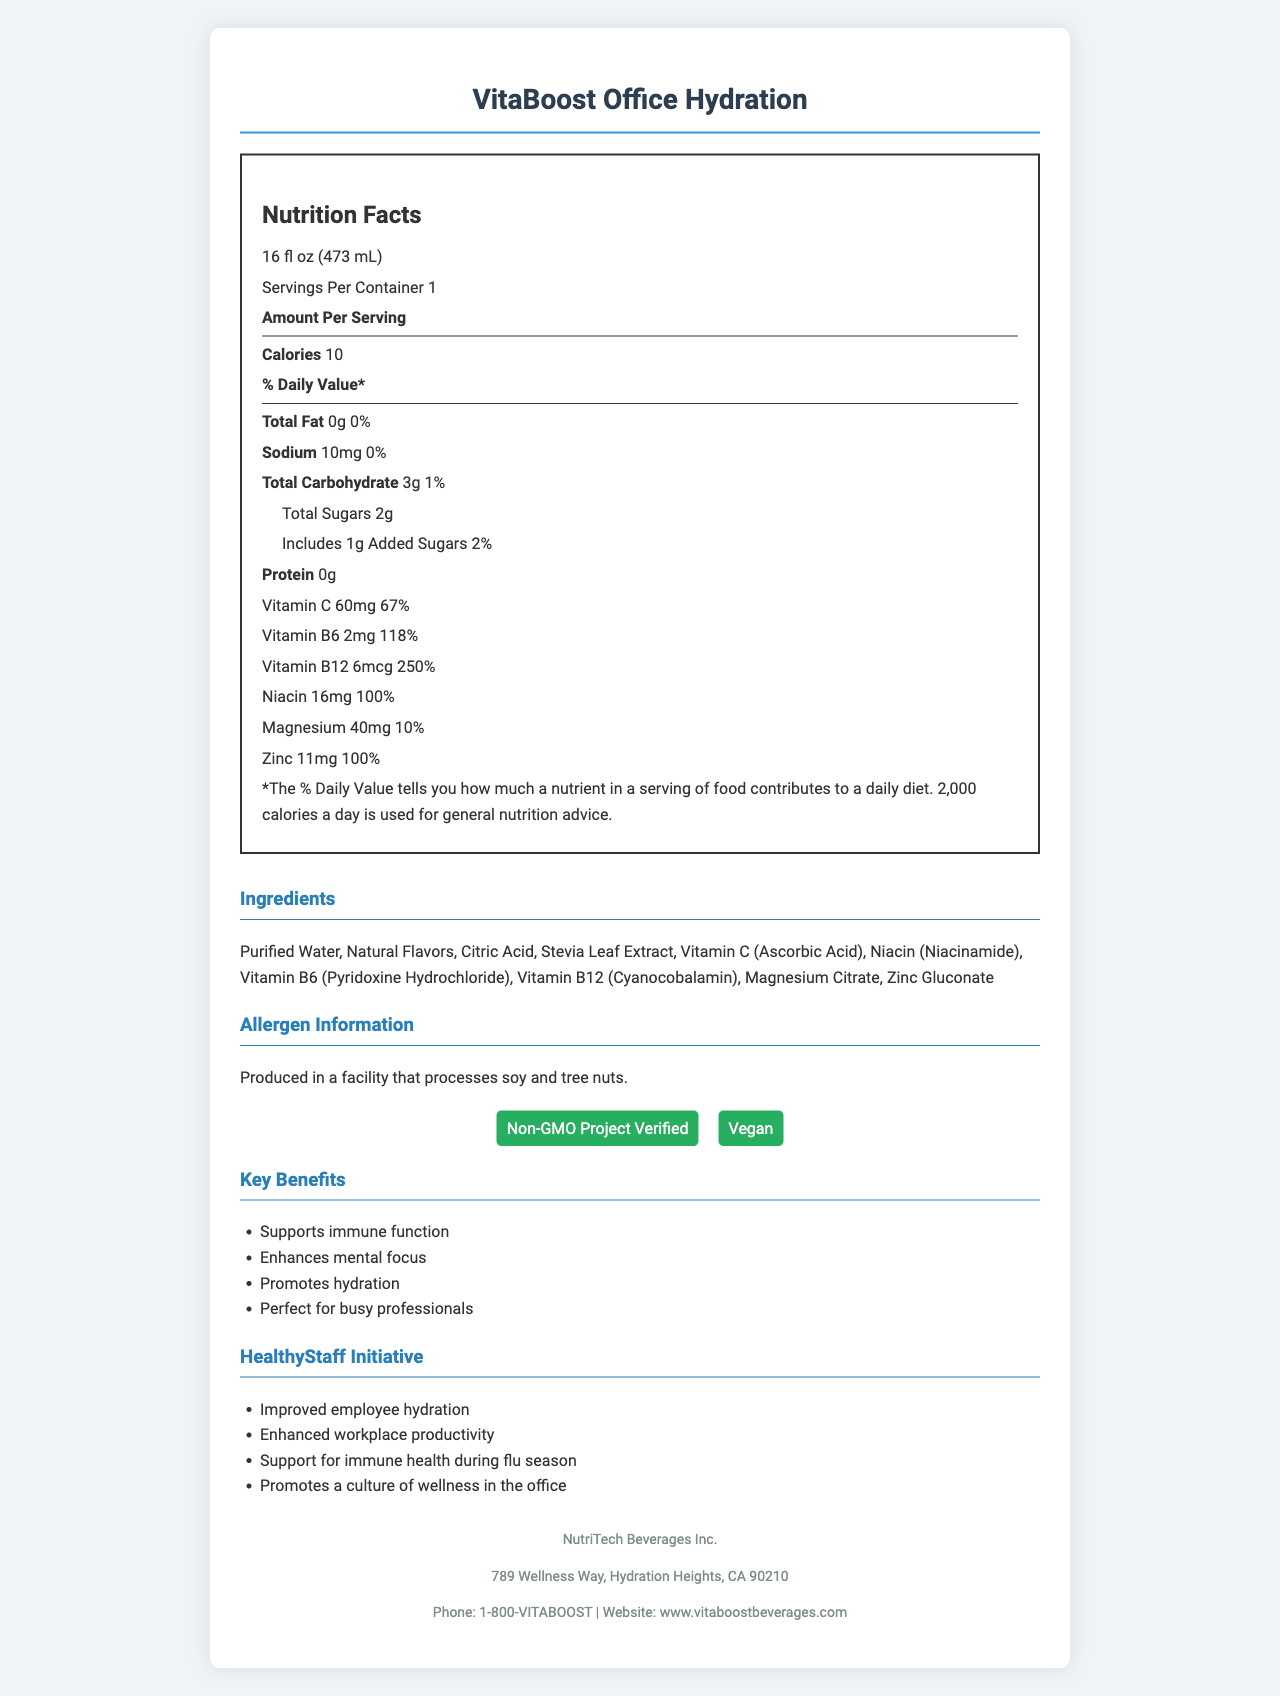What is the serving size of VitaBoost Office Hydration? The serving size is clearly mentioned at the beginning of the nutrition facts section as "16 fl oz (473 mL)".
Answer: 16 fl oz (473 mL) How many calories are there per serving? The number of calories per serving is listed directly under "Amount Per Serving" in the document.
Answer: 10 List two vitamins present in VitaBoost Office Hydration and their daily values. The vitamins are listed along with their amounts and daily values in the nutrition facts section.
Answer: Vitamin C (67%), Vitamin B6 (118%) What is the daily value percentage of Zinc in this beverage? The daily value percentage of Zinc is mentioned in the minerals section as "100%".
Answer: 100% Name the two certifications that VitaBoost Office Hydration has. The certifications are displayed under the certifications section as "Non-GMO Project Verified" and "Vegan".
Answer: Non-GMO Project Verified, Vegan What type of flavors are used in VitaBoost Office Hydration? A. Artificial Flavors B. Natural Flavors C. Fruit Flavors The ingredients list includes "Natural Flavors", indicating the type used.
Answer: B How much sodium is in a serving of this beverage? A. 0 mg B. 5 mg C. 10 mg The document lists the sodium content as "10 mg".
Answer: C Does the beverage contain any added sugars? The nutrition facts state that it includes 1g of added sugars with a daily value of 2%.
Answer: Yes Is VitaBoost Office Hydration suitable for vegans? The document mentions in the certifications section that the beverage is "Vegan".
Answer: Yes Summarize the main idea of the document. This summary covers the key points about the product’s nutritional content, certifications, intended benefits, and suggested usage in a workplace wellness program.
Answer: VitaBoost Office Hydration is a vitamin-fortified beverage designed to support workplace wellness. It contains low calories, various vitamins and minerals, and no fat or protein. It is certified Non-GMO and Vegan and claims to enhance hydration, mental focus, and immune function. The drink is recommended for office use to improve employee well-being and productivity. What are the implementation tips for incorporating VitaBoost Office Hydration into the office environment? While implementation tips are part of the broader benefits in the hrWellnessProgram data, they are not visible in the visual document presented.
Answer: Cannot be determined Which vitamin has the highest daily value percentage in the beverage? A. Vitamin C B. Vitamin B6 C. Vitamin B12 D. Niacin Vitamin B12 has the highest daily value percentage at 250%, as shown in the nutrition facts section.
Answer: C 